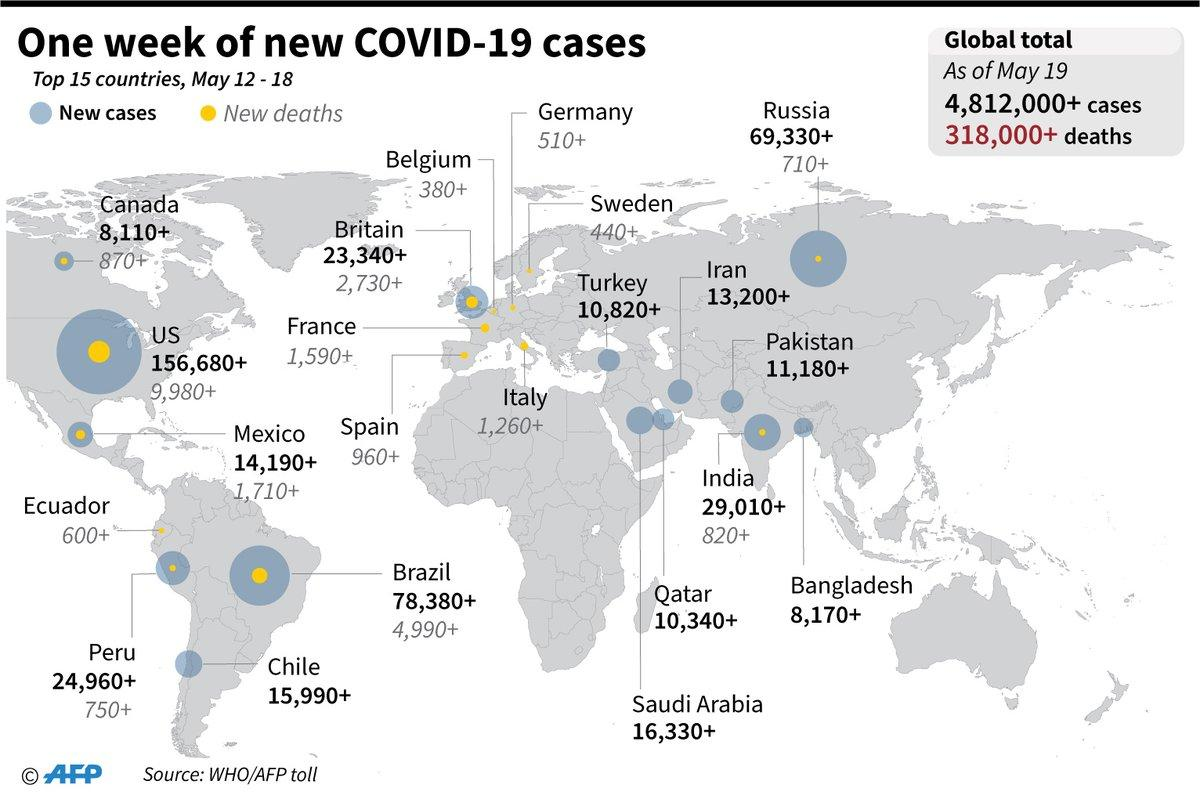List a handful of essential elements in this visual. The difference between "new cases" and "new deaths" in Brazil refers to the number of individuals who have contracted COVID-19 for the first time and the number of individuals who have died from COVID-19, respectively. The specific number mentioned, 73,390+, refers to the most recent and accurate data on the number of new cases and new deaths in Brazil. The number of new cases and new deaths in India are two separate statistical measures. New cases refer to the number of new instances of a disease or condition that have been diagnosed, while new deaths refer to the number of people who have died as a result of that same disease or condition. The difference between new cases and new deaths in Canada is 7240+. The difference between new cases and new deaths in Russia is 68,620 plus... 